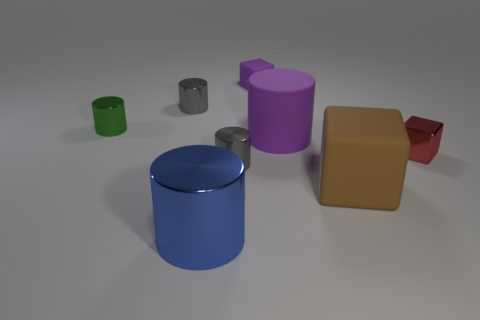The rubber block that is the same color as the big matte cylinder is what size?
Offer a terse response. Small. What size is the gray object on the left side of the gray cylinder right of the big shiny cylinder?
Your response must be concise. Small. There is a gray metal cylinder in front of the large purple cylinder; what size is it?
Your answer should be very brief. Small. Are there fewer small gray metallic cylinders that are on the right side of the big metallic cylinder than tiny purple rubber objects on the right side of the metallic block?
Your response must be concise. No. The big rubber cylinder is what color?
Ensure brevity in your answer.  Purple. Are there any objects of the same color as the metal block?
Offer a terse response. No. There is a purple rubber thing right of the tiny thing that is behind the gray metal cylinder on the left side of the blue metallic cylinder; what is its shape?
Offer a very short reply. Cylinder. What is the large cylinder to the right of the purple matte cube made of?
Provide a succinct answer. Rubber. There is a metal thing that is on the right side of the tiny gray object in front of the cylinder that is on the right side of the small purple thing; what size is it?
Make the answer very short. Small. There is a blue shiny cylinder; is it the same size as the purple rubber thing behind the green thing?
Your answer should be compact. No. 